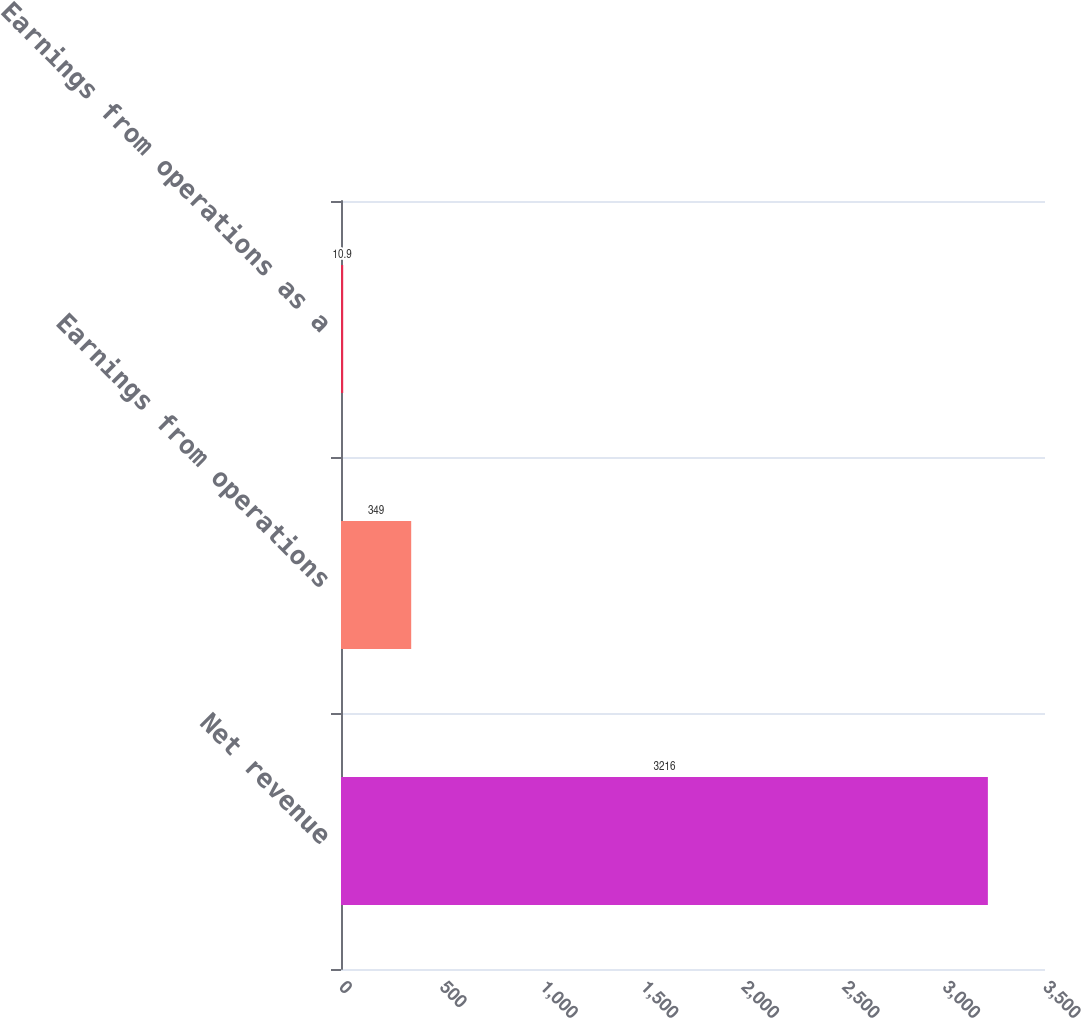<chart> <loc_0><loc_0><loc_500><loc_500><bar_chart><fcel>Net revenue<fcel>Earnings from operations<fcel>Earnings from operations as a<nl><fcel>3216<fcel>349<fcel>10.9<nl></chart> 